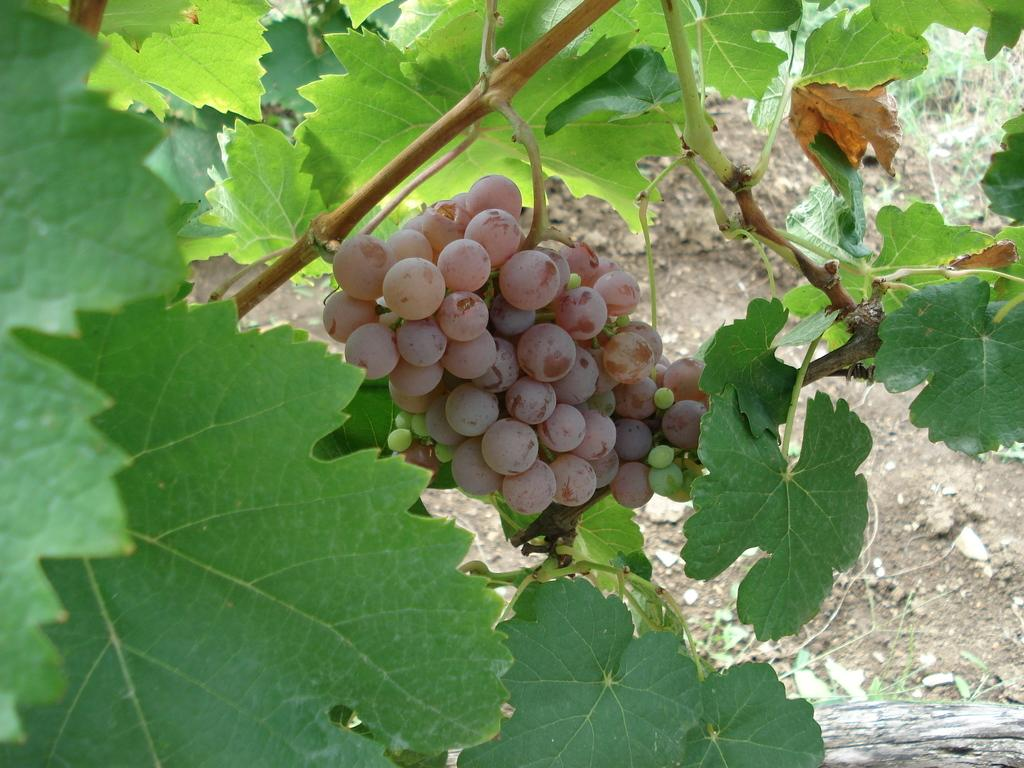Where was the image taken? The image was taken outdoors. What can be seen on the left side of the image? There is a creeper with green leaves and grapes on the left side of the image. What type of vegetation is visible in the background of the image? There is a ground with grass in the background of the image. How many children are playing with the pear in the image? There are no children or pears present in the image. 